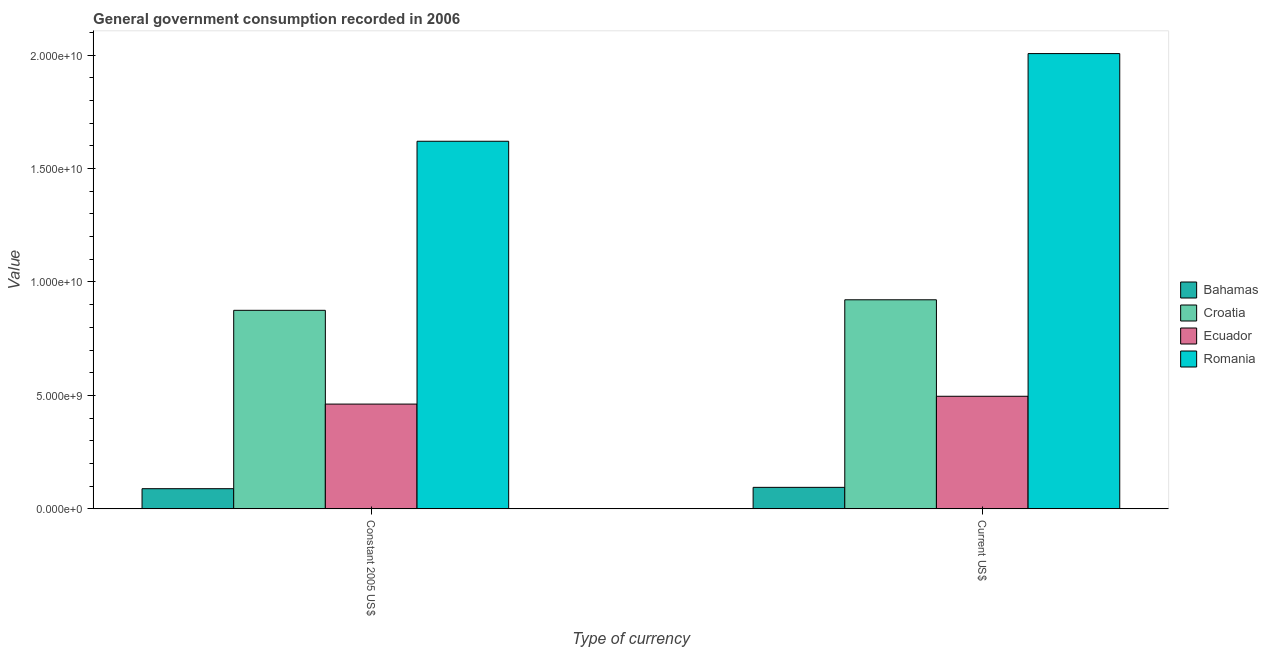How many different coloured bars are there?
Your answer should be very brief. 4. Are the number of bars per tick equal to the number of legend labels?
Offer a very short reply. Yes. Are the number of bars on each tick of the X-axis equal?
Provide a succinct answer. Yes. How many bars are there on the 1st tick from the left?
Ensure brevity in your answer.  4. How many bars are there on the 2nd tick from the right?
Ensure brevity in your answer.  4. What is the label of the 1st group of bars from the left?
Keep it short and to the point. Constant 2005 US$. What is the value consumed in constant 2005 us$ in Bahamas?
Provide a succinct answer. 8.88e+08. Across all countries, what is the maximum value consumed in constant 2005 us$?
Ensure brevity in your answer.  1.62e+1. Across all countries, what is the minimum value consumed in constant 2005 us$?
Make the answer very short. 8.88e+08. In which country was the value consumed in constant 2005 us$ maximum?
Provide a short and direct response. Romania. In which country was the value consumed in current us$ minimum?
Give a very brief answer. Bahamas. What is the total value consumed in constant 2005 us$ in the graph?
Your answer should be compact. 3.05e+1. What is the difference between the value consumed in current us$ in Romania and that in Bahamas?
Make the answer very short. 1.91e+1. What is the difference between the value consumed in current us$ in Ecuador and the value consumed in constant 2005 us$ in Romania?
Provide a succinct answer. -1.12e+1. What is the average value consumed in current us$ per country?
Your response must be concise. 8.80e+09. What is the difference between the value consumed in constant 2005 us$ and value consumed in current us$ in Ecuador?
Offer a terse response. -3.44e+08. What is the ratio of the value consumed in constant 2005 us$ in Croatia to that in Bahamas?
Make the answer very short. 9.85. What does the 4th bar from the left in Current US$ represents?
Provide a succinct answer. Romania. What does the 3rd bar from the right in Constant 2005 US$ represents?
Your answer should be very brief. Croatia. How many bars are there?
Your answer should be compact. 8. What is the difference between two consecutive major ticks on the Y-axis?
Your answer should be very brief. 5.00e+09. Are the values on the major ticks of Y-axis written in scientific E-notation?
Offer a terse response. Yes. Does the graph contain any zero values?
Your answer should be compact. No. Does the graph contain grids?
Offer a terse response. No. Where does the legend appear in the graph?
Give a very brief answer. Center right. How many legend labels are there?
Ensure brevity in your answer.  4. How are the legend labels stacked?
Your response must be concise. Vertical. What is the title of the graph?
Provide a succinct answer. General government consumption recorded in 2006. Does "Pacific island small states" appear as one of the legend labels in the graph?
Your answer should be very brief. No. What is the label or title of the X-axis?
Offer a terse response. Type of currency. What is the label or title of the Y-axis?
Your answer should be compact. Value. What is the Value of Bahamas in Constant 2005 US$?
Give a very brief answer. 8.88e+08. What is the Value in Croatia in Constant 2005 US$?
Give a very brief answer. 8.75e+09. What is the Value in Ecuador in Constant 2005 US$?
Give a very brief answer. 4.62e+09. What is the Value in Romania in Constant 2005 US$?
Make the answer very short. 1.62e+1. What is the Value in Bahamas in Current US$?
Give a very brief answer. 9.48e+08. What is the Value in Croatia in Current US$?
Provide a succinct answer. 9.21e+09. What is the Value in Ecuador in Current US$?
Your answer should be compact. 4.96e+09. What is the Value of Romania in Current US$?
Provide a short and direct response. 2.01e+1. Across all Type of currency, what is the maximum Value in Bahamas?
Your answer should be very brief. 9.48e+08. Across all Type of currency, what is the maximum Value of Croatia?
Your answer should be compact. 9.21e+09. Across all Type of currency, what is the maximum Value of Ecuador?
Keep it short and to the point. 4.96e+09. Across all Type of currency, what is the maximum Value of Romania?
Provide a short and direct response. 2.01e+1. Across all Type of currency, what is the minimum Value in Bahamas?
Provide a short and direct response. 8.88e+08. Across all Type of currency, what is the minimum Value of Croatia?
Provide a short and direct response. 8.75e+09. Across all Type of currency, what is the minimum Value of Ecuador?
Give a very brief answer. 4.62e+09. Across all Type of currency, what is the minimum Value in Romania?
Offer a terse response. 1.62e+1. What is the total Value in Bahamas in the graph?
Give a very brief answer. 1.84e+09. What is the total Value in Croatia in the graph?
Offer a very short reply. 1.80e+1. What is the total Value in Ecuador in the graph?
Your answer should be compact. 9.58e+09. What is the total Value of Romania in the graph?
Your response must be concise. 3.63e+1. What is the difference between the Value in Bahamas in Constant 2005 US$ and that in Current US$?
Offer a very short reply. -5.91e+07. What is the difference between the Value in Croatia in Constant 2005 US$ and that in Current US$?
Provide a succinct answer. -4.64e+08. What is the difference between the Value of Ecuador in Constant 2005 US$ and that in Current US$?
Provide a short and direct response. -3.44e+08. What is the difference between the Value of Romania in Constant 2005 US$ and that in Current US$?
Your response must be concise. -3.86e+09. What is the difference between the Value in Bahamas in Constant 2005 US$ and the Value in Croatia in Current US$?
Make the answer very short. -8.33e+09. What is the difference between the Value in Bahamas in Constant 2005 US$ and the Value in Ecuador in Current US$?
Your answer should be very brief. -4.07e+09. What is the difference between the Value in Bahamas in Constant 2005 US$ and the Value in Romania in Current US$?
Your answer should be compact. -1.92e+1. What is the difference between the Value in Croatia in Constant 2005 US$ and the Value in Ecuador in Current US$?
Your response must be concise. 3.79e+09. What is the difference between the Value in Croatia in Constant 2005 US$ and the Value in Romania in Current US$?
Your answer should be compact. -1.13e+1. What is the difference between the Value in Ecuador in Constant 2005 US$ and the Value in Romania in Current US$?
Offer a very short reply. -1.54e+1. What is the average Value in Bahamas per Type of currency?
Ensure brevity in your answer.  9.18e+08. What is the average Value in Croatia per Type of currency?
Give a very brief answer. 8.98e+09. What is the average Value in Ecuador per Type of currency?
Your response must be concise. 4.79e+09. What is the average Value of Romania per Type of currency?
Provide a succinct answer. 1.81e+1. What is the difference between the Value of Bahamas and Value of Croatia in Constant 2005 US$?
Keep it short and to the point. -7.86e+09. What is the difference between the Value in Bahamas and Value in Ecuador in Constant 2005 US$?
Provide a succinct answer. -3.73e+09. What is the difference between the Value of Bahamas and Value of Romania in Constant 2005 US$?
Give a very brief answer. -1.53e+1. What is the difference between the Value in Croatia and Value in Ecuador in Constant 2005 US$?
Your answer should be compact. 4.13e+09. What is the difference between the Value in Croatia and Value in Romania in Constant 2005 US$?
Offer a very short reply. -7.45e+09. What is the difference between the Value of Ecuador and Value of Romania in Constant 2005 US$?
Offer a very short reply. -1.16e+1. What is the difference between the Value of Bahamas and Value of Croatia in Current US$?
Offer a very short reply. -8.27e+09. What is the difference between the Value of Bahamas and Value of Ecuador in Current US$?
Your answer should be very brief. -4.01e+09. What is the difference between the Value of Bahamas and Value of Romania in Current US$?
Keep it short and to the point. -1.91e+1. What is the difference between the Value in Croatia and Value in Ecuador in Current US$?
Offer a very short reply. 4.25e+09. What is the difference between the Value in Croatia and Value in Romania in Current US$?
Your answer should be very brief. -1.09e+1. What is the difference between the Value in Ecuador and Value in Romania in Current US$?
Your answer should be very brief. -1.51e+1. What is the ratio of the Value in Bahamas in Constant 2005 US$ to that in Current US$?
Offer a very short reply. 0.94. What is the ratio of the Value of Croatia in Constant 2005 US$ to that in Current US$?
Keep it short and to the point. 0.95. What is the ratio of the Value in Ecuador in Constant 2005 US$ to that in Current US$?
Your answer should be compact. 0.93. What is the ratio of the Value of Romania in Constant 2005 US$ to that in Current US$?
Keep it short and to the point. 0.81. What is the difference between the highest and the second highest Value in Bahamas?
Your answer should be very brief. 5.91e+07. What is the difference between the highest and the second highest Value of Croatia?
Give a very brief answer. 4.64e+08. What is the difference between the highest and the second highest Value in Ecuador?
Your answer should be very brief. 3.44e+08. What is the difference between the highest and the second highest Value of Romania?
Provide a succinct answer. 3.86e+09. What is the difference between the highest and the lowest Value of Bahamas?
Provide a short and direct response. 5.91e+07. What is the difference between the highest and the lowest Value in Croatia?
Make the answer very short. 4.64e+08. What is the difference between the highest and the lowest Value in Ecuador?
Offer a very short reply. 3.44e+08. What is the difference between the highest and the lowest Value in Romania?
Ensure brevity in your answer.  3.86e+09. 